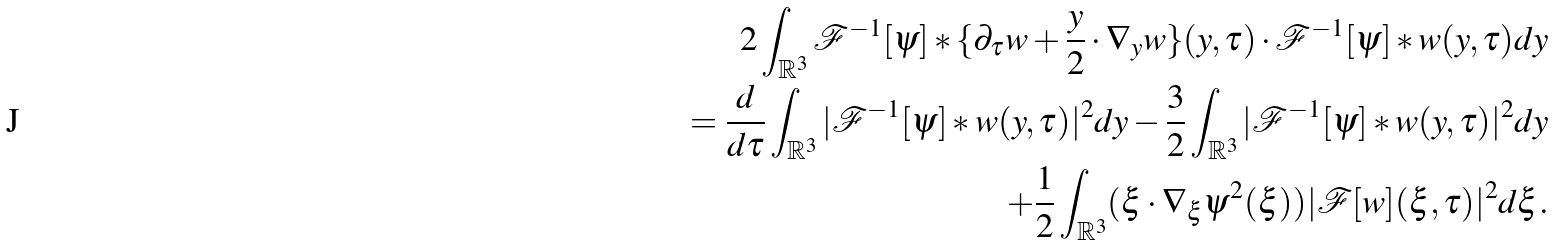Convert formula to latex. <formula><loc_0><loc_0><loc_500><loc_500>2 \int _ { \mathbb { R } ^ { 3 } } \mathcal { F } ^ { - 1 } [ \psi ] \ast \{ \partial _ { \tau } w + \frac { y } 2 \cdot \nabla _ { y } w \} ( y , \tau ) \cdot \mathcal { F } ^ { - 1 } [ \psi ] \ast w ( y , \tau ) d y \\ = \frac { d } { d \tau } \int _ { \mathbb { R } ^ { 3 } } | \mathcal { F } ^ { - 1 } [ \psi ] \ast w ( y , \tau ) | ^ { 2 } d y - \frac { 3 } { 2 } \int _ { \mathbb { R } ^ { 3 } } | \mathcal { F } ^ { - 1 } [ \psi ] \ast w ( y , \tau ) | ^ { 2 } d y \\ + \frac { 1 } { 2 } \int _ { \mathbb { R } ^ { 3 } } ( \xi \cdot \nabla _ { \xi } \psi ^ { 2 } ( \xi ) ) | \mathcal { F } [ w ] ( \xi , \tau ) | ^ { 2 } d \xi .</formula> 